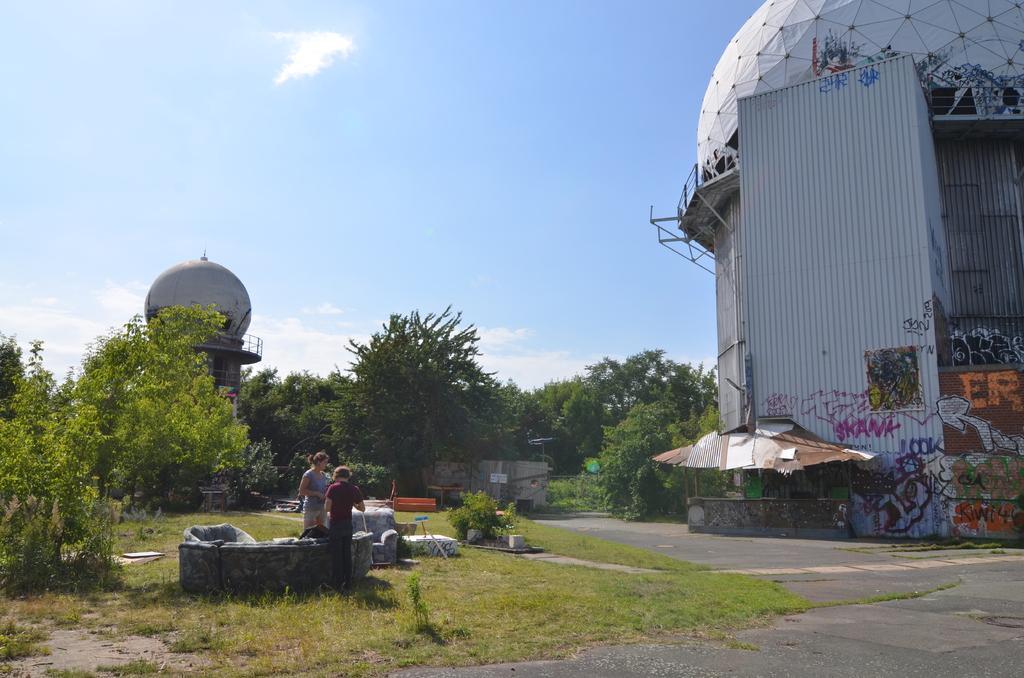Please provide a concise description of this image. In this image two people are standing on the grassland having sofas. Right side there is a stall. A person is in the stall. Background there are buildings and trees. Top of the image there is sky. Bottom of the image there is a road. 